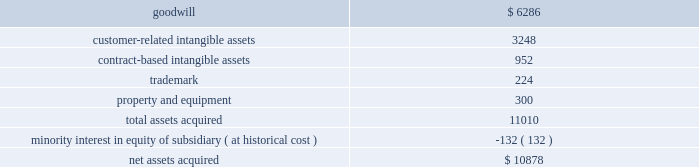Notes to consolidated financial statements 2014 ( continued ) owns the remaining 44% ( 44 % ) .
We purchased our share of gpap philippines for $ 10.9 million .
The purpose of this acquisition was to expand our presence in the asia-pacific market .
This business acquisition was not significant to our consolidated financial statements and accordingly , we have not provided pro forma information relating to this acquisition .
The table summarizes the preliminary purchase price allocation ( in thousands ) : .
All of the goodwill associated with the acquisition is non-deductible for tax purposes .
The customer-related intangible assets have amortization periods of 11 years .
The contract-based intangible assets have amortization periods of 7 years .
The trademark has an amortization period of 5 years .
Money transfer branch locations during 2009 , we completed the second and final series of money transfer branch location acquisitions in the united states as part of an assignment and asset purchase agreement with a privately held company .
The purpose of this acquisition was to increase the market presence of our dolex-branded money transfer offering .
The purchase price of these acquisitions was $ 787 thousand with $ 739 thousand allocated to goodwill and $ 48 thousand allocated to intangibles .
Pursuant to our annual impairment test in fiscal 2009 , goodwill and other intangibles related to our money transfer business were deemed impaired .
Please see note 3 2014impairment charges for further information .
This business acquisition was not significant to our consolidated financial statements and accordingly , we have not provided pro forma information relating to this acquisition .
Fiscal 2008 discover during the year ended may 31 , 2008 , we acquired a portfolio of merchants that process discover transactions and the rights to process discover transactions for our existing and new merchants for $ 6.0 million .
The purchase of the portfolio was structured to occur in tranches .
During fiscal 2009 , additional tranches were purchased for $ 1.4 million .
As a result of this acquisition , we now process discover transactions similarly to how we currently process visa and mastercard transactions .
The purpose of this acquisition was to offer merchants a single point of contact for discover , visa and mastercard card processing .
The operating results of the acquired portfolio have been included in our consolidated financial statements from the dates of acquisition .
The customer-related intangible assets have amortization periods of 10 years .
These business acquisitions were not significant to our consolidated financial statements and accordingly , we have not provided pro forma information relating to these acquisitions. .
What percent of the assets , purchased in the acquisition , are tangible? 
Rationale: tangible assets do not include goodwill , nontangible assets , and trademark . therefore we must divide equipment by total assets .
Computations: (300 + 11010)
Answer: 11310.0. Notes to consolidated financial statements 2014 ( continued ) owns the remaining 44% ( 44 % ) .
We purchased our share of gpap philippines for $ 10.9 million .
The purpose of this acquisition was to expand our presence in the asia-pacific market .
This business acquisition was not significant to our consolidated financial statements and accordingly , we have not provided pro forma information relating to this acquisition .
The table summarizes the preliminary purchase price allocation ( in thousands ) : .
All of the goodwill associated with the acquisition is non-deductible for tax purposes .
The customer-related intangible assets have amortization periods of 11 years .
The contract-based intangible assets have amortization periods of 7 years .
The trademark has an amortization period of 5 years .
Money transfer branch locations during 2009 , we completed the second and final series of money transfer branch location acquisitions in the united states as part of an assignment and asset purchase agreement with a privately held company .
The purpose of this acquisition was to increase the market presence of our dolex-branded money transfer offering .
The purchase price of these acquisitions was $ 787 thousand with $ 739 thousand allocated to goodwill and $ 48 thousand allocated to intangibles .
Pursuant to our annual impairment test in fiscal 2009 , goodwill and other intangibles related to our money transfer business were deemed impaired .
Please see note 3 2014impairment charges for further information .
This business acquisition was not significant to our consolidated financial statements and accordingly , we have not provided pro forma information relating to this acquisition .
Fiscal 2008 discover during the year ended may 31 , 2008 , we acquired a portfolio of merchants that process discover transactions and the rights to process discover transactions for our existing and new merchants for $ 6.0 million .
The purchase of the portfolio was structured to occur in tranches .
During fiscal 2009 , additional tranches were purchased for $ 1.4 million .
As a result of this acquisition , we now process discover transactions similarly to how we currently process visa and mastercard transactions .
The purpose of this acquisition was to offer merchants a single point of contact for discover , visa and mastercard card processing .
The operating results of the acquired portfolio have been included in our consolidated financial statements from the dates of acquisition .
The customer-related intangible assets have amortization periods of 10 years .
These business acquisitions were not significant to our consolidated financial statements and accordingly , we have not provided pro forma information relating to these acquisitions. .
What is the yearly amortization expense related to customer-related intangible assets , ( in thousands ) ? 
Computations: (3248 / 11)
Answer: 295.27273. Notes to consolidated financial statements 2014 ( continued ) owns the remaining 44% ( 44 % ) .
We purchased our share of gpap philippines for $ 10.9 million .
The purpose of this acquisition was to expand our presence in the asia-pacific market .
This business acquisition was not significant to our consolidated financial statements and accordingly , we have not provided pro forma information relating to this acquisition .
The table summarizes the preliminary purchase price allocation ( in thousands ) : .
All of the goodwill associated with the acquisition is non-deductible for tax purposes .
The customer-related intangible assets have amortization periods of 11 years .
The contract-based intangible assets have amortization periods of 7 years .
The trademark has an amortization period of 5 years .
Money transfer branch locations during 2009 , we completed the second and final series of money transfer branch location acquisitions in the united states as part of an assignment and asset purchase agreement with a privately held company .
The purpose of this acquisition was to increase the market presence of our dolex-branded money transfer offering .
The purchase price of these acquisitions was $ 787 thousand with $ 739 thousand allocated to goodwill and $ 48 thousand allocated to intangibles .
Pursuant to our annual impairment test in fiscal 2009 , goodwill and other intangibles related to our money transfer business were deemed impaired .
Please see note 3 2014impairment charges for further information .
This business acquisition was not significant to our consolidated financial statements and accordingly , we have not provided pro forma information relating to this acquisition .
Fiscal 2008 discover during the year ended may 31 , 2008 , we acquired a portfolio of merchants that process discover transactions and the rights to process discover transactions for our existing and new merchants for $ 6.0 million .
The purchase of the portfolio was structured to occur in tranches .
During fiscal 2009 , additional tranches were purchased for $ 1.4 million .
As a result of this acquisition , we now process discover transactions similarly to how we currently process visa and mastercard transactions .
The purpose of this acquisition was to offer merchants a single point of contact for discover , visa and mastercard card processing .
The operating results of the acquired portfolio have been included in our consolidated financial statements from the dates of acquisition .
The customer-related intangible assets have amortization periods of 10 years .
These business acquisitions were not significant to our consolidated financial statements and accordingly , we have not provided pro forma information relating to these acquisitions. .
What percent of the assets , purchased in the acquisition , are tangible? 
Rationale: tangible assets do not include goodwill , nontangible assets , and trademark . therefore we must divide equipment by total assets .
Computations: (300 + 11010)
Answer: 11310.0. Notes to consolidated financial statements 2014 ( continued ) owns the remaining 44% ( 44 % ) .
We purchased our share of gpap philippines for $ 10.9 million .
The purpose of this acquisition was to expand our presence in the asia-pacific market .
This business acquisition was not significant to our consolidated financial statements and accordingly , we have not provided pro forma information relating to this acquisition .
The table summarizes the preliminary purchase price allocation ( in thousands ) : .
All of the goodwill associated with the acquisition is non-deductible for tax purposes .
The customer-related intangible assets have amortization periods of 11 years .
The contract-based intangible assets have amortization periods of 7 years .
The trademark has an amortization period of 5 years .
Money transfer branch locations during 2009 , we completed the second and final series of money transfer branch location acquisitions in the united states as part of an assignment and asset purchase agreement with a privately held company .
The purpose of this acquisition was to increase the market presence of our dolex-branded money transfer offering .
The purchase price of these acquisitions was $ 787 thousand with $ 739 thousand allocated to goodwill and $ 48 thousand allocated to intangibles .
Pursuant to our annual impairment test in fiscal 2009 , goodwill and other intangibles related to our money transfer business were deemed impaired .
Please see note 3 2014impairment charges for further information .
This business acquisition was not significant to our consolidated financial statements and accordingly , we have not provided pro forma information relating to this acquisition .
Fiscal 2008 discover during the year ended may 31 , 2008 , we acquired a portfolio of merchants that process discover transactions and the rights to process discover transactions for our existing and new merchants for $ 6.0 million .
The purchase of the portfolio was structured to occur in tranches .
During fiscal 2009 , additional tranches were purchased for $ 1.4 million .
As a result of this acquisition , we now process discover transactions similarly to how we currently process visa and mastercard transactions .
The purpose of this acquisition was to offer merchants a single point of contact for discover , visa and mastercard card processing .
The operating results of the acquired portfolio have been included in our consolidated financial statements from the dates of acquisition .
The customer-related intangible assets have amortization periods of 10 years .
These business acquisitions were not significant to our consolidated financial statements and accordingly , we have not provided pro forma information relating to these acquisitions. .
What is the yearly amortization expense related to trademark , ( in thousands ) ? 
Computations: (224 / 5)
Answer: 44.8. 